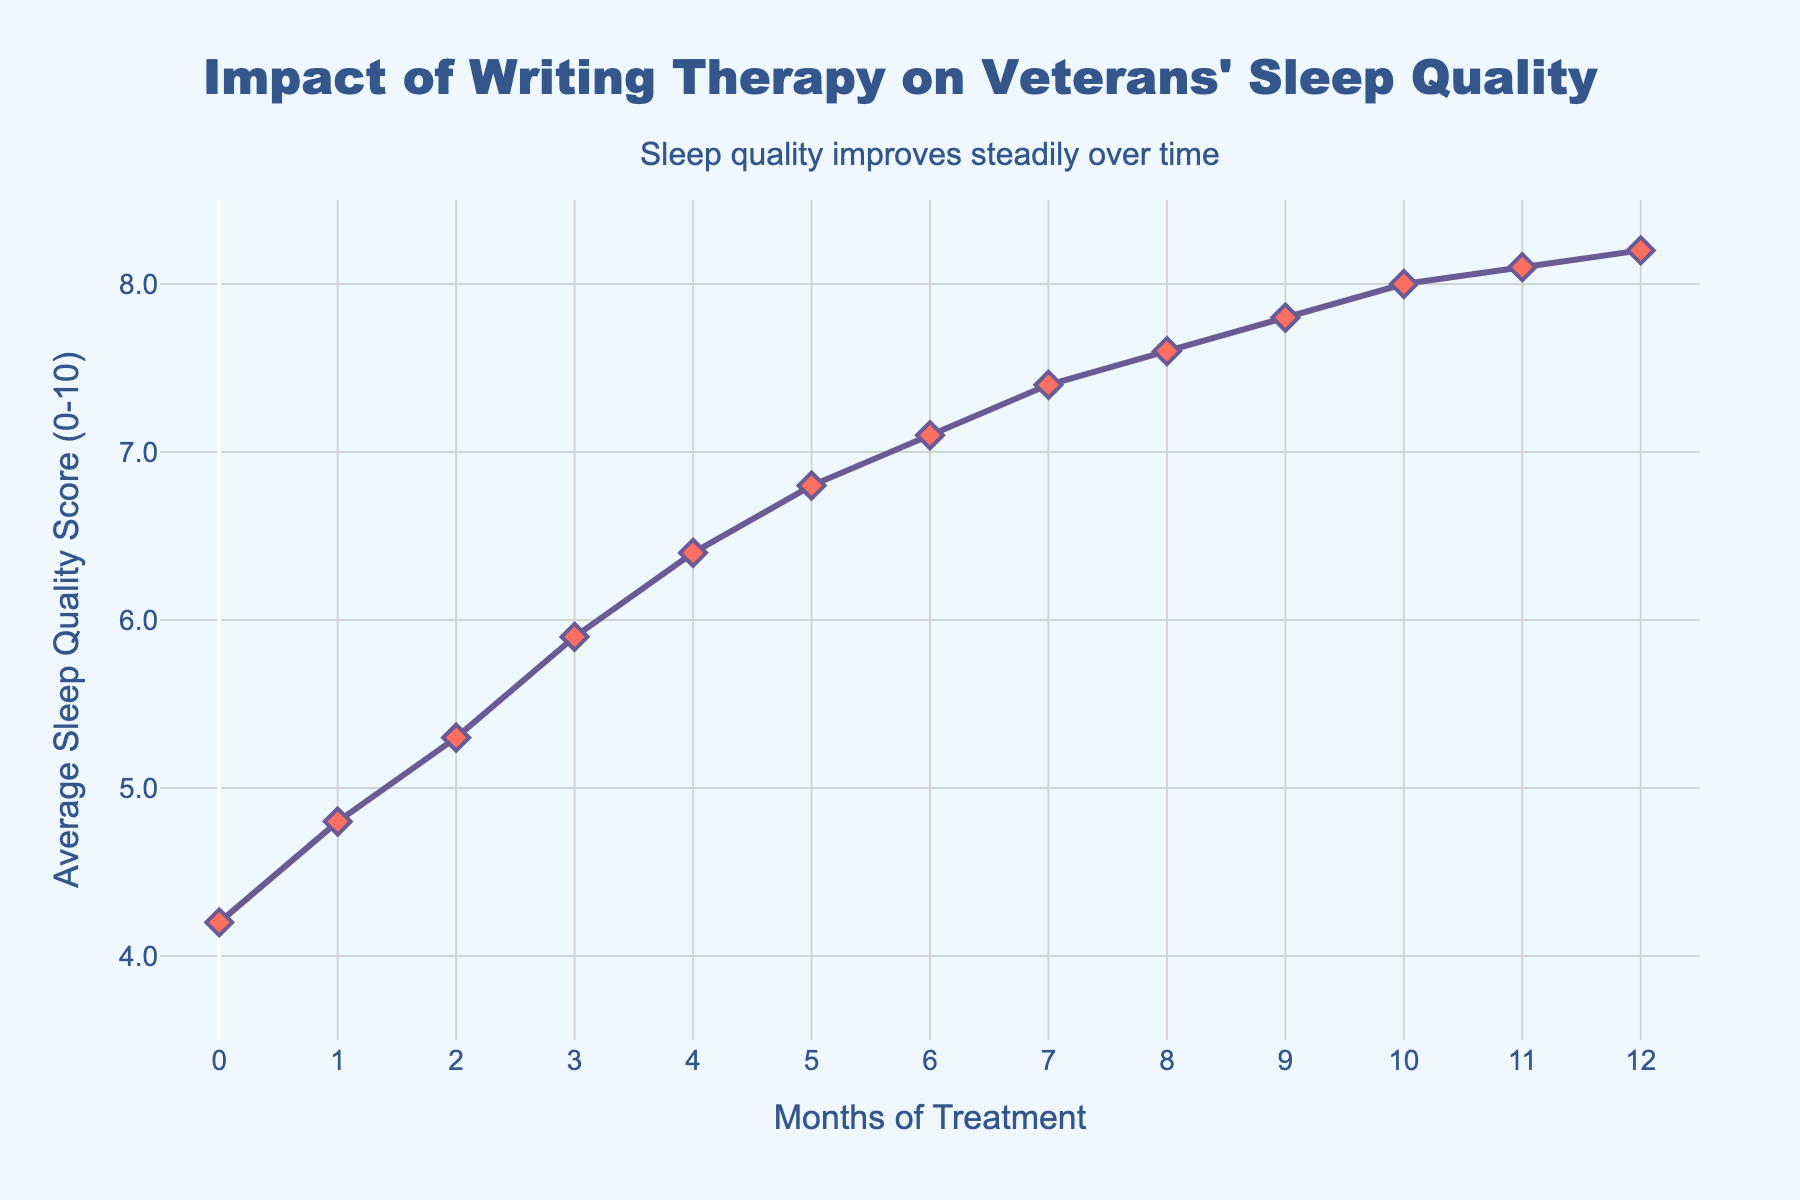What is the sleep quality score at month 6? Locate the point on the line chart corresponding to month 6 on the x-axis. Read the y-axis value for this point.
Answer: 7.1 How much did the sleep quality score improve from month 0 to month 12? Find the scores at months 0 and 12. Subtract the score at month 0 from the score at month 12. 8.2 - 4.2 = 4.0
Answer: 4.0 Was the month-to-month increase in sleep quality score always greater than 0.2? Examine the increase in scores between each consecutive month. The smallest increase is between months 11 and 12, which is 8.2 - 8.1 = 0.1, so not always greater than 0.2.
Answer: No Is the increase from month 1 to month 2 greater than the increase from month 5 to month 6? Calculate the increase between month 1 to month 2 (5.3 - 4.8 = 0.5) and from month 5 to month 6 (7.1 - 6.8 = 0.3). Compare the two values.
Answer: Yes How many months did it take for the sleep quality score to exceed 7? Identify the point at which the sleep quality score exceeds 7 for the first time. This occurs at month 7.
Answer: 7 